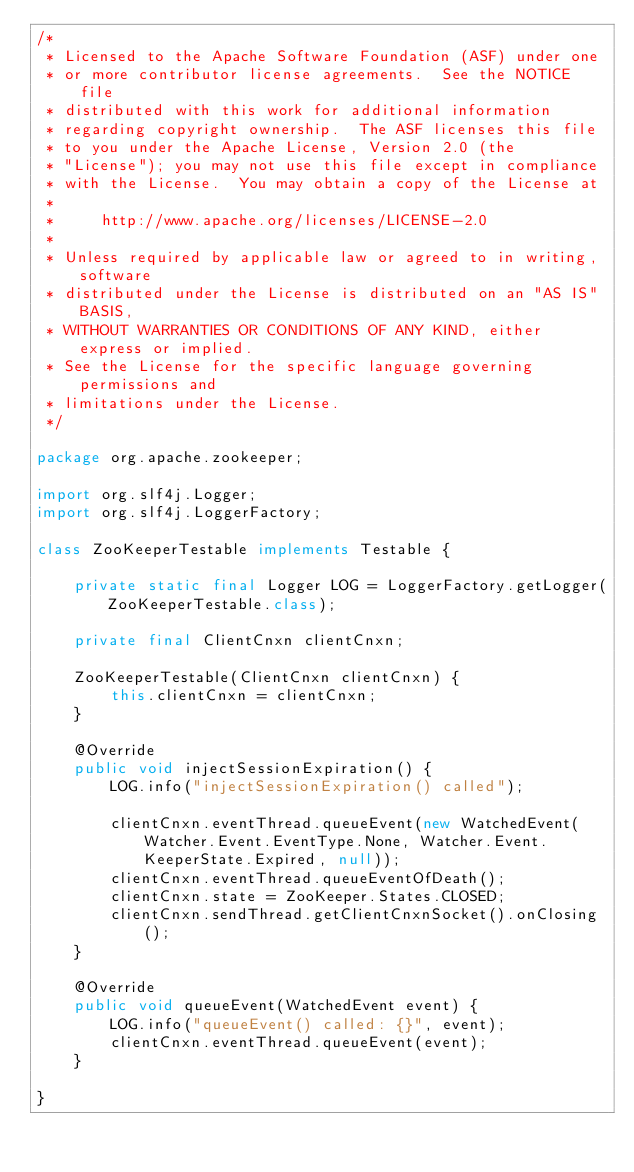<code> <loc_0><loc_0><loc_500><loc_500><_Java_>/*
 * Licensed to the Apache Software Foundation (ASF) under one
 * or more contributor license agreements.  See the NOTICE file
 * distributed with this work for additional information
 * regarding copyright ownership.  The ASF licenses this file
 * to you under the Apache License, Version 2.0 (the
 * "License"); you may not use this file except in compliance
 * with the License.  You may obtain a copy of the License at
 *
 *     http://www.apache.org/licenses/LICENSE-2.0
 *
 * Unless required by applicable law or agreed to in writing, software
 * distributed under the License is distributed on an "AS IS" BASIS,
 * WITHOUT WARRANTIES OR CONDITIONS OF ANY KIND, either express or implied.
 * See the License for the specific language governing permissions and
 * limitations under the License.
 */

package org.apache.zookeeper;

import org.slf4j.Logger;
import org.slf4j.LoggerFactory;

class ZooKeeperTestable implements Testable {

    private static final Logger LOG = LoggerFactory.getLogger(ZooKeeperTestable.class);

    private final ClientCnxn clientCnxn;

    ZooKeeperTestable(ClientCnxn clientCnxn) {
        this.clientCnxn = clientCnxn;
    }

    @Override
    public void injectSessionExpiration() {
        LOG.info("injectSessionExpiration() called");

        clientCnxn.eventThread.queueEvent(new WatchedEvent(Watcher.Event.EventType.None, Watcher.Event.KeeperState.Expired, null));
        clientCnxn.eventThread.queueEventOfDeath();
        clientCnxn.state = ZooKeeper.States.CLOSED;
        clientCnxn.sendThread.getClientCnxnSocket().onClosing();
    }

    @Override
    public void queueEvent(WatchedEvent event) {
        LOG.info("queueEvent() called: {}", event);
        clientCnxn.eventThread.queueEvent(event);
    }

}
</code> 